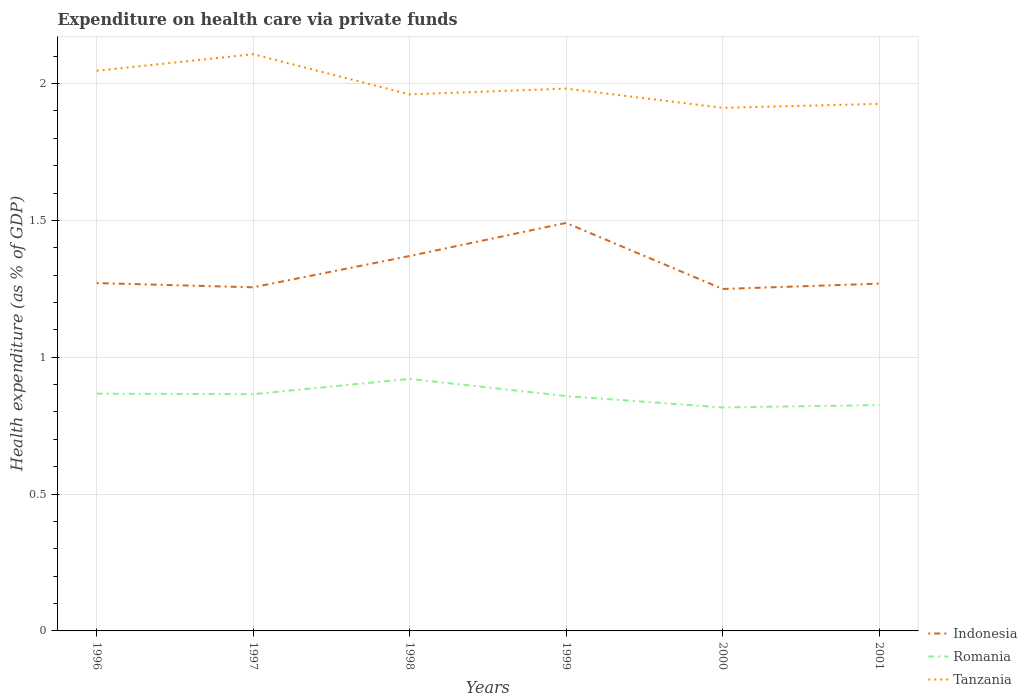How many different coloured lines are there?
Give a very brief answer. 3. Does the line corresponding to Romania intersect with the line corresponding to Tanzania?
Keep it short and to the point. No. Across all years, what is the maximum expenditure made on health care in Tanzania?
Give a very brief answer. 1.91. What is the total expenditure made on health care in Indonesia in the graph?
Keep it short and to the point. -0.22. What is the difference between the highest and the second highest expenditure made on health care in Tanzania?
Offer a very short reply. 0.2. Is the expenditure made on health care in Indonesia strictly greater than the expenditure made on health care in Romania over the years?
Offer a very short reply. No. How many years are there in the graph?
Offer a very short reply. 6. Does the graph contain any zero values?
Ensure brevity in your answer.  No. Does the graph contain grids?
Give a very brief answer. Yes. Where does the legend appear in the graph?
Offer a terse response. Bottom right. What is the title of the graph?
Your answer should be very brief. Expenditure on health care via private funds. What is the label or title of the X-axis?
Give a very brief answer. Years. What is the label or title of the Y-axis?
Offer a very short reply. Health expenditure (as % of GDP). What is the Health expenditure (as % of GDP) in Indonesia in 1996?
Ensure brevity in your answer.  1.27. What is the Health expenditure (as % of GDP) of Romania in 1996?
Give a very brief answer. 0.87. What is the Health expenditure (as % of GDP) in Tanzania in 1996?
Provide a succinct answer. 2.05. What is the Health expenditure (as % of GDP) of Indonesia in 1997?
Your answer should be compact. 1.26. What is the Health expenditure (as % of GDP) of Romania in 1997?
Your answer should be very brief. 0.87. What is the Health expenditure (as % of GDP) of Tanzania in 1997?
Keep it short and to the point. 2.11. What is the Health expenditure (as % of GDP) in Indonesia in 1998?
Your answer should be very brief. 1.37. What is the Health expenditure (as % of GDP) of Romania in 1998?
Make the answer very short. 0.92. What is the Health expenditure (as % of GDP) in Tanzania in 1998?
Offer a terse response. 1.96. What is the Health expenditure (as % of GDP) of Indonesia in 1999?
Your response must be concise. 1.49. What is the Health expenditure (as % of GDP) in Romania in 1999?
Keep it short and to the point. 0.86. What is the Health expenditure (as % of GDP) in Tanzania in 1999?
Offer a very short reply. 1.98. What is the Health expenditure (as % of GDP) of Indonesia in 2000?
Keep it short and to the point. 1.25. What is the Health expenditure (as % of GDP) in Romania in 2000?
Make the answer very short. 0.82. What is the Health expenditure (as % of GDP) of Tanzania in 2000?
Keep it short and to the point. 1.91. What is the Health expenditure (as % of GDP) of Indonesia in 2001?
Make the answer very short. 1.27. What is the Health expenditure (as % of GDP) in Romania in 2001?
Offer a terse response. 0.83. What is the Health expenditure (as % of GDP) in Tanzania in 2001?
Ensure brevity in your answer.  1.93. Across all years, what is the maximum Health expenditure (as % of GDP) of Indonesia?
Make the answer very short. 1.49. Across all years, what is the maximum Health expenditure (as % of GDP) in Romania?
Offer a terse response. 0.92. Across all years, what is the maximum Health expenditure (as % of GDP) in Tanzania?
Keep it short and to the point. 2.11. Across all years, what is the minimum Health expenditure (as % of GDP) of Indonesia?
Your answer should be very brief. 1.25. Across all years, what is the minimum Health expenditure (as % of GDP) in Romania?
Offer a terse response. 0.82. Across all years, what is the minimum Health expenditure (as % of GDP) of Tanzania?
Make the answer very short. 1.91. What is the total Health expenditure (as % of GDP) of Indonesia in the graph?
Give a very brief answer. 7.91. What is the total Health expenditure (as % of GDP) in Romania in the graph?
Offer a terse response. 5.15. What is the total Health expenditure (as % of GDP) of Tanzania in the graph?
Give a very brief answer. 11.93. What is the difference between the Health expenditure (as % of GDP) of Indonesia in 1996 and that in 1997?
Provide a short and direct response. 0.02. What is the difference between the Health expenditure (as % of GDP) in Romania in 1996 and that in 1997?
Give a very brief answer. 0. What is the difference between the Health expenditure (as % of GDP) of Tanzania in 1996 and that in 1997?
Keep it short and to the point. -0.06. What is the difference between the Health expenditure (as % of GDP) of Indonesia in 1996 and that in 1998?
Offer a very short reply. -0.1. What is the difference between the Health expenditure (as % of GDP) in Romania in 1996 and that in 1998?
Give a very brief answer. -0.05. What is the difference between the Health expenditure (as % of GDP) of Tanzania in 1996 and that in 1998?
Provide a short and direct response. 0.09. What is the difference between the Health expenditure (as % of GDP) in Indonesia in 1996 and that in 1999?
Keep it short and to the point. -0.22. What is the difference between the Health expenditure (as % of GDP) of Romania in 1996 and that in 1999?
Give a very brief answer. 0.01. What is the difference between the Health expenditure (as % of GDP) in Tanzania in 1996 and that in 1999?
Provide a succinct answer. 0.07. What is the difference between the Health expenditure (as % of GDP) of Indonesia in 1996 and that in 2000?
Ensure brevity in your answer.  0.02. What is the difference between the Health expenditure (as % of GDP) of Romania in 1996 and that in 2000?
Your response must be concise. 0.05. What is the difference between the Health expenditure (as % of GDP) in Tanzania in 1996 and that in 2000?
Provide a short and direct response. 0.14. What is the difference between the Health expenditure (as % of GDP) in Indonesia in 1996 and that in 2001?
Make the answer very short. 0. What is the difference between the Health expenditure (as % of GDP) of Romania in 1996 and that in 2001?
Make the answer very short. 0.04. What is the difference between the Health expenditure (as % of GDP) in Tanzania in 1996 and that in 2001?
Keep it short and to the point. 0.12. What is the difference between the Health expenditure (as % of GDP) of Indonesia in 1997 and that in 1998?
Provide a succinct answer. -0.11. What is the difference between the Health expenditure (as % of GDP) in Romania in 1997 and that in 1998?
Ensure brevity in your answer.  -0.06. What is the difference between the Health expenditure (as % of GDP) in Tanzania in 1997 and that in 1998?
Your response must be concise. 0.15. What is the difference between the Health expenditure (as % of GDP) in Indonesia in 1997 and that in 1999?
Your response must be concise. -0.24. What is the difference between the Health expenditure (as % of GDP) of Romania in 1997 and that in 1999?
Your answer should be compact. 0.01. What is the difference between the Health expenditure (as % of GDP) in Tanzania in 1997 and that in 1999?
Offer a very short reply. 0.13. What is the difference between the Health expenditure (as % of GDP) in Indonesia in 1997 and that in 2000?
Offer a terse response. 0.01. What is the difference between the Health expenditure (as % of GDP) in Romania in 1997 and that in 2000?
Keep it short and to the point. 0.05. What is the difference between the Health expenditure (as % of GDP) of Tanzania in 1997 and that in 2000?
Keep it short and to the point. 0.2. What is the difference between the Health expenditure (as % of GDP) in Indonesia in 1997 and that in 2001?
Your answer should be compact. -0.01. What is the difference between the Health expenditure (as % of GDP) in Romania in 1997 and that in 2001?
Your answer should be very brief. 0.04. What is the difference between the Health expenditure (as % of GDP) of Tanzania in 1997 and that in 2001?
Your response must be concise. 0.18. What is the difference between the Health expenditure (as % of GDP) of Indonesia in 1998 and that in 1999?
Your answer should be very brief. -0.12. What is the difference between the Health expenditure (as % of GDP) in Romania in 1998 and that in 1999?
Keep it short and to the point. 0.06. What is the difference between the Health expenditure (as % of GDP) of Tanzania in 1998 and that in 1999?
Provide a short and direct response. -0.02. What is the difference between the Health expenditure (as % of GDP) in Indonesia in 1998 and that in 2000?
Make the answer very short. 0.12. What is the difference between the Health expenditure (as % of GDP) in Romania in 1998 and that in 2000?
Ensure brevity in your answer.  0.1. What is the difference between the Health expenditure (as % of GDP) in Tanzania in 1998 and that in 2000?
Make the answer very short. 0.05. What is the difference between the Health expenditure (as % of GDP) in Indonesia in 1998 and that in 2001?
Your answer should be compact. 0.1. What is the difference between the Health expenditure (as % of GDP) of Romania in 1998 and that in 2001?
Ensure brevity in your answer.  0.1. What is the difference between the Health expenditure (as % of GDP) in Tanzania in 1998 and that in 2001?
Ensure brevity in your answer.  0.03. What is the difference between the Health expenditure (as % of GDP) in Indonesia in 1999 and that in 2000?
Offer a very short reply. 0.24. What is the difference between the Health expenditure (as % of GDP) in Romania in 1999 and that in 2000?
Give a very brief answer. 0.04. What is the difference between the Health expenditure (as % of GDP) in Tanzania in 1999 and that in 2000?
Your answer should be very brief. 0.07. What is the difference between the Health expenditure (as % of GDP) of Indonesia in 1999 and that in 2001?
Ensure brevity in your answer.  0.22. What is the difference between the Health expenditure (as % of GDP) of Romania in 1999 and that in 2001?
Keep it short and to the point. 0.03. What is the difference between the Health expenditure (as % of GDP) in Tanzania in 1999 and that in 2001?
Provide a succinct answer. 0.06. What is the difference between the Health expenditure (as % of GDP) in Indonesia in 2000 and that in 2001?
Make the answer very short. -0.02. What is the difference between the Health expenditure (as % of GDP) in Romania in 2000 and that in 2001?
Give a very brief answer. -0.01. What is the difference between the Health expenditure (as % of GDP) in Tanzania in 2000 and that in 2001?
Offer a very short reply. -0.01. What is the difference between the Health expenditure (as % of GDP) of Indonesia in 1996 and the Health expenditure (as % of GDP) of Romania in 1997?
Your response must be concise. 0.41. What is the difference between the Health expenditure (as % of GDP) in Indonesia in 1996 and the Health expenditure (as % of GDP) in Tanzania in 1997?
Your answer should be compact. -0.84. What is the difference between the Health expenditure (as % of GDP) in Romania in 1996 and the Health expenditure (as % of GDP) in Tanzania in 1997?
Give a very brief answer. -1.24. What is the difference between the Health expenditure (as % of GDP) of Indonesia in 1996 and the Health expenditure (as % of GDP) of Romania in 1998?
Your response must be concise. 0.35. What is the difference between the Health expenditure (as % of GDP) in Indonesia in 1996 and the Health expenditure (as % of GDP) in Tanzania in 1998?
Provide a succinct answer. -0.69. What is the difference between the Health expenditure (as % of GDP) in Romania in 1996 and the Health expenditure (as % of GDP) in Tanzania in 1998?
Provide a short and direct response. -1.09. What is the difference between the Health expenditure (as % of GDP) of Indonesia in 1996 and the Health expenditure (as % of GDP) of Romania in 1999?
Provide a succinct answer. 0.41. What is the difference between the Health expenditure (as % of GDP) in Indonesia in 1996 and the Health expenditure (as % of GDP) in Tanzania in 1999?
Your answer should be compact. -0.71. What is the difference between the Health expenditure (as % of GDP) of Romania in 1996 and the Health expenditure (as % of GDP) of Tanzania in 1999?
Make the answer very short. -1.11. What is the difference between the Health expenditure (as % of GDP) in Indonesia in 1996 and the Health expenditure (as % of GDP) in Romania in 2000?
Provide a succinct answer. 0.45. What is the difference between the Health expenditure (as % of GDP) in Indonesia in 1996 and the Health expenditure (as % of GDP) in Tanzania in 2000?
Offer a terse response. -0.64. What is the difference between the Health expenditure (as % of GDP) of Romania in 1996 and the Health expenditure (as % of GDP) of Tanzania in 2000?
Ensure brevity in your answer.  -1.04. What is the difference between the Health expenditure (as % of GDP) of Indonesia in 1996 and the Health expenditure (as % of GDP) of Romania in 2001?
Provide a succinct answer. 0.45. What is the difference between the Health expenditure (as % of GDP) in Indonesia in 1996 and the Health expenditure (as % of GDP) in Tanzania in 2001?
Provide a short and direct response. -0.65. What is the difference between the Health expenditure (as % of GDP) of Romania in 1996 and the Health expenditure (as % of GDP) of Tanzania in 2001?
Your answer should be compact. -1.06. What is the difference between the Health expenditure (as % of GDP) of Indonesia in 1997 and the Health expenditure (as % of GDP) of Romania in 1998?
Your response must be concise. 0.33. What is the difference between the Health expenditure (as % of GDP) in Indonesia in 1997 and the Health expenditure (as % of GDP) in Tanzania in 1998?
Give a very brief answer. -0.7. What is the difference between the Health expenditure (as % of GDP) of Romania in 1997 and the Health expenditure (as % of GDP) of Tanzania in 1998?
Your answer should be compact. -1.1. What is the difference between the Health expenditure (as % of GDP) of Indonesia in 1997 and the Health expenditure (as % of GDP) of Romania in 1999?
Offer a very short reply. 0.4. What is the difference between the Health expenditure (as % of GDP) of Indonesia in 1997 and the Health expenditure (as % of GDP) of Tanzania in 1999?
Provide a succinct answer. -0.73. What is the difference between the Health expenditure (as % of GDP) in Romania in 1997 and the Health expenditure (as % of GDP) in Tanzania in 1999?
Ensure brevity in your answer.  -1.12. What is the difference between the Health expenditure (as % of GDP) of Indonesia in 1997 and the Health expenditure (as % of GDP) of Romania in 2000?
Ensure brevity in your answer.  0.44. What is the difference between the Health expenditure (as % of GDP) in Indonesia in 1997 and the Health expenditure (as % of GDP) in Tanzania in 2000?
Your answer should be compact. -0.66. What is the difference between the Health expenditure (as % of GDP) in Romania in 1997 and the Health expenditure (as % of GDP) in Tanzania in 2000?
Keep it short and to the point. -1.05. What is the difference between the Health expenditure (as % of GDP) of Indonesia in 1997 and the Health expenditure (as % of GDP) of Romania in 2001?
Ensure brevity in your answer.  0.43. What is the difference between the Health expenditure (as % of GDP) of Indonesia in 1997 and the Health expenditure (as % of GDP) of Tanzania in 2001?
Offer a terse response. -0.67. What is the difference between the Health expenditure (as % of GDP) of Romania in 1997 and the Health expenditure (as % of GDP) of Tanzania in 2001?
Offer a terse response. -1.06. What is the difference between the Health expenditure (as % of GDP) of Indonesia in 1998 and the Health expenditure (as % of GDP) of Romania in 1999?
Your answer should be compact. 0.51. What is the difference between the Health expenditure (as % of GDP) in Indonesia in 1998 and the Health expenditure (as % of GDP) in Tanzania in 1999?
Offer a terse response. -0.61. What is the difference between the Health expenditure (as % of GDP) in Romania in 1998 and the Health expenditure (as % of GDP) in Tanzania in 1999?
Give a very brief answer. -1.06. What is the difference between the Health expenditure (as % of GDP) of Indonesia in 1998 and the Health expenditure (as % of GDP) of Romania in 2000?
Provide a succinct answer. 0.55. What is the difference between the Health expenditure (as % of GDP) of Indonesia in 1998 and the Health expenditure (as % of GDP) of Tanzania in 2000?
Your answer should be very brief. -0.54. What is the difference between the Health expenditure (as % of GDP) of Romania in 1998 and the Health expenditure (as % of GDP) of Tanzania in 2000?
Offer a terse response. -0.99. What is the difference between the Health expenditure (as % of GDP) in Indonesia in 1998 and the Health expenditure (as % of GDP) in Romania in 2001?
Your answer should be very brief. 0.54. What is the difference between the Health expenditure (as % of GDP) of Indonesia in 1998 and the Health expenditure (as % of GDP) of Tanzania in 2001?
Offer a very short reply. -0.56. What is the difference between the Health expenditure (as % of GDP) of Romania in 1998 and the Health expenditure (as % of GDP) of Tanzania in 2001?
Give a very brief answer. -1. What is the difference between the Health expenditure (as % of GDP) of Indonesia in 1999 and the Health expenditure (as % of GDP) of Romania in 2000?
Ensure brevity in your answer.  0.67. What is the difference between the Health expenditure (as % of GDP) in Indonesia in 1999 and the Health expenditure (as % of GDP) in Tanzania in 2000?
Give a very brief answer. -0.42. What is the difference between the Health expenditure (as % of GDP) of Romania in 1999 and the Health expenditure (as % of GDP) of Tanzania in 2000?
Your answer should be very brief. -1.05. What is the difference between the Health expenditure (as % of GDP) in Indonesia in 1999 and the Health expenditure (as % of GDP) in Romania in 2001?
Your answer should be very brief. 0.67. What is the difference between the Health expenditure (as % of GDP) of Indonesia in 1999 and the Health expenditure (as % of GDP) of Tanzania in 2001?
Offer a terse response. -0.43. What is the difference between the Health expenditure (as % of GDP) of Romania in 1999 and the Health expenditure (as % of GDP) of Tanzania in 2001?
Provide a succinct answer. -1.07. What is the difference between the Health expenditure (as % of GDP) in Indonesia in 2000 and the Health expenditure (as % of GDP) in Romania in 2001?
Offer a very short reply. 0.42. What is the difference between the Health expenditure (as % of GDP) of Indonesia in 2000 and the Health expenditure (as % of GDP) of Tanzania in 2001?
Ensure brevity in your answer.  -0.68. What is the difference between the Health expenditure (as % of GDP) in Romania in 2000 and the Health expenditure (as % of GDP) in Tanzania in 2001?
Provide a succinct answer. -1.11. What is the average Health expenditure (as % of GDP) of Indonesia per year?
Offer a very short reply. 1.32. What is the average Health expenditure (as % of GDP) in Romania per year?
Your response must be concise. 0.86. What is the average Health expenditure (as % of GDP) in Tanzania per year?
Give a very brief answer. 1.99. In the year 1996, what is the difference between the Health expenditure (as % of GDP) in Indonesia and Health expenditure (as % of GDP) in Romania?
Ensure brevity in your answer.  0.4. In the year 1996, what is the difference between the Health expenditure (as % of GDP) in Indonesia and Health expenditure (as % of GDP) in Tanzania?
Ensure brevity in your answer.  -0.78. In the year 1996, what is the difference between the Health expenditure (as % of GDP) in Romania and Health expenditure (as % of GDP) in Tanzania?
Provide a short and direct response. -1.18. In the year 1997, what is the difference between the Health expenditure (as % of GDP) of Indonesia and Health expenditure (as % of GDP) of Romania?
Give a very brief answer. 0.39. In the year 1997, what is the difference between the Health expenditure (as % of GDP) in Indonesia and Health expenditure (as % of GDP) in Tanzania?
Provide a succinct answer. -0.85. In the year 1997, what is the difference between the Health expenditure (as % of GDP) in Romania and Health expenditure (as % of GDP) in Tanzania?
Your response must be concise. -1.24. In the year 1998, what is the difference between the Health expenditure (as % of GDP) of Indonesia and Health expenditure (as % of GDP) of Romania?
Offer a terse response. 0.45. In the year 1998, what is the difference between the Health expenditure (as % of GDP) in Indonesia and Health expenditure (as % of GDP) in Tanzania?
Offer a terse response. -0.59. In the year 1998, what is the difference between the Health expenditure (as % of GDP) in Romania and Health expenditure (as % of GDP) in Tanzania?
Make the answer very short. -1.04. In the year 1999, what is the difference between the Health expenditure (as % of GDP) in Indonesia and Health expenditure (as % of GDP) in Romania?
Your response must be concise. 0.63. In the year 1999, what is the difference between the Health expenditure (as % of GDP) in Indonesia and Health expenditure (as % of GDP) in Tanzania?
Offer a terse response. -0.49. In the year 1999, what is the difference between the Health expenditure (as % of GDP) of Romania and Health expenditure (as % of GDP) of Tanzania?
Keep it short and to the point. -1.12. In the year 2000, what is the difference between the Health expenditure (as % of GDP) in Indonesia and Health expenditure (as % of GDP) in Romania?
Provide a short and direct response. 0.43. In the year 2000, what is the difference between the Health expenditure (as % of GDP) in Indonesia and Health expenditure (as % of GDP) in Tanzania?
Your response must be concise. -0.66. In the year 2000, what is the difference between the Health expenditure (as % of GDP) of Romania and Health expenditure (as % of GDP) of Tanzania?
Offer a very short reply. -1.09. In the year 2001, what is the difference between the Health expenditure (as % of GDP) of Indonesia and Health expenditure (as % of GDP) of Romania?
Your response must be concise. 0.44. In the year 2001, what is the difference between the Health expenditure (as % of GDP) in Indonesia and Health expenditure (as % of GDP) in Tanzania?
Keep it short and to the point. -0.66. In the year 2001, what is the difference between the Health expenditure (as % of GDP) of Romania and Health expenditure (as % of GDP) of Tanzania?
Your answer should be compact. -1.1. What is the ratio of the Health expenditure (as % of GDP) of Indonesia in 1996 to that in 1997?
Your response must be concise. 1.01. What is the ratio of the Health expenditure (as % of GDP) in Tanzania in 1996 to that in 1997?
Give a very brief answer. 0.97. What is the ratio of the Health expenditure (as % of GDP) in Indonesia in 1996 to that in 1998?
Make the answer very short. 0.93. What is the ratio of the Health expenditure (as % of GDP) of Romania in 1996 to that in 1998?
Make the answer very short. 0.94. What is the ratio of the Health expenditure (as % of GDP) of Tanzania in 1996 to that in 1998?
Your answer should be very brief. 1.04. What is the ratio of the Health expenditure (as % of GDP) of Indonesia in 1996 to that in 1999?
Give a very brief answer. 0.85. What is the ratio of the Health expenditure (as % of GDP) of Tanzania in 1996 to that in 1999?
Keep it short and to the point. 1.03. What is the ratio of the Health expenditure (as % of GDP) in Indonesia in 1996 to that in 2000?
Your answer should be very brief. 1.02. What is the ratio of the Health expenditure (as % of GDP) of Romania in 1996 to that in 2000?
Offer a very short reply. 1.06. What is the ratio of the Health expenditure (as % of GDP) of Tanzania in 1996 to that in 2000?
Give a very brief answer. 1.07. What is the ratio of the Health expenditure (as % of GDP) of Indonesia in 1996 to that in 2001?
Make the answer very short. 1. What is the ratio of the Health expenditure (as % of GDP) in Romania in 1996 to that in 2001?
Give a very brief answer. 1.05. What is the ratio of the Health expenditure (as % of GDP) in Tanzania in 1996 to that in 2001?
Ensure brevity in your answer.  1.06. What is the ratio of the Health expenditure (as % of GDP) of Indonesia in 1997 to that in 1998?
Your answer should be very brief. 0.92. What is the ratio of the Health expenditure (as % of GDP) of Romania in 1997 to that in 1998?
Ensure brevity in your answer.  0.94. What is the ratio of the Health expenditure (as % of GDP) in Tanzania in 1997 to that in 1998?
Ensure brevity in your answer.  1.07. What is the ratio of the Health expenditure (as % of GDP) of Indonesia in 1997 to that in 1999?
Provide a short and direct response. 0.84. What is the ratio of the Health expenditure (as % of GDP) in Tanzania in 1997 to that in 1999?
Provide a short and direct response. 1.06. What is the ratio of the Health expenditure (as % of GDP) of Indonesia in 1997 to that in 2000?
Your answer should be very brief. 1. What is the ratio of the Health expenditure (as % of GDP) in Romania in 1997 to that in 2000?
Your response must be concise. 1.06. What is the ratio of the Health expenditure (as % of GDP) of Tanzania in 1997 to that in 2000?
Offer a terse response. 1.1. What is the ratio of the Health expenditure (as % of GDP) of Indonesia in 1997 to that in 2001?
Offer a very short reply. 0.99. What is the ratio of the Health expenditure (as % of GDP) in Romania in 1997 to that in 2001?
Make the answer very short. 1.05. What is the ratio of the Health expenditure (as % of GDP) of Tanzania in 1997 to that in 2001?
Ensure brevity in your answer.  1.09. What is the ratio of the Health expenditure (as % of GDP) in Indonesia in 1998 to that in 1999?
Your answer should be compact. 0.92. What is the ratio of the Health expenditure (as % of GDP) in Romania in 1998 to that in 1999?
Provide a succinct answer. 1.07. What is the ratio of the Health expenditure (as % of GDP) in Tanzania in 1998 to that in 1999?
Provide a succinct answer. 0.99. What is the ratio of the Health expenditure (as % of GDP) in Indonesia in 1998 to that in 2000?
Ensure brevity in your answer.  1.1. What is the ratio of the Health expenditure (as % of GDP) of Romania in 1998 to that in 2000?
Provide a short and direct response. 1.13. What is the ratio of the Health expenditure (as % of GDP) of Tanzania in 1998 to that in 2000?
Your response must be concise. 1.03. What is the ratio of the Health expenditure (as % of GDP) of Indonesia in 1998 to that in 2001?
Your response must be concise. 1.08. What is the ratio of the Health expenditure (as % of GDP) of Romania in 1998 to that in 2001?
Your answer should be very brief. 1.12. What is the ratio of the Health expenditure (as % of GDP) in Tanzania in 1998 to that in 2001?
Make the answer very short. 1.02. What is the ratio of the Health expenditure (as % of GDP) of Indonesia in 1999 to that in 2000?
Give a very brief answer. 1.19. What is the ratio of the Health expenditure (as % of GDP) of Romania in 1999 to that in 2000?
Your answer should be compact. 1.05. What is the ratio of the Health expenditure (as % of GDP) of Tanzania in 1999 to that in 2000?
Your answer should be compact. 1.04. What is the ratio of the Health expenditure (as % of GDP) in Indonesia in 1999 to that in 2001?
Your answer should be very brief. 1.17. What is the ratio of the Health expenditure (as % of GDP) of Romania in 1999 to that in 2001?
Your answer should be very brief. 1.04. What is the ratio of the Health expenditure (as % of GDP) in Indonesia in 2000 to that in 2001?
Offer a very short reply. 0.98. What is the ratio of the Health expenditure (as % of GDP) of Romania in 2000 to that in 2001?
Ensure brevity in your answer.  0.99. What is the difference between the highest and the second highest Health expenditure (as % of GDP) in Indonesia?
Offer a very short reply. 0.12. What is the difference between the highest and the second highest Health expenditure (as % of GDP) of Romania?
Keep it short and to the point. 0.05. What is the difference between the highest and the second highest Health expenditure (as % of GDP) in Tanzania?
Provide a short and direct response. 0.06. What is the difference between the highest and the lowest Health expenditure (as % of GDP) in Indonesia?
Offer a terse response. 0.24. What is the difference between the highest and the lowest Health expenditure (as % of GDP) in Romania?
Keep it short and to the point. 0.1. What is the difference between the highest and the lowest Health expenditure (as % of GDP) of Tanzania?
Give a very brief answer. 0.2. 